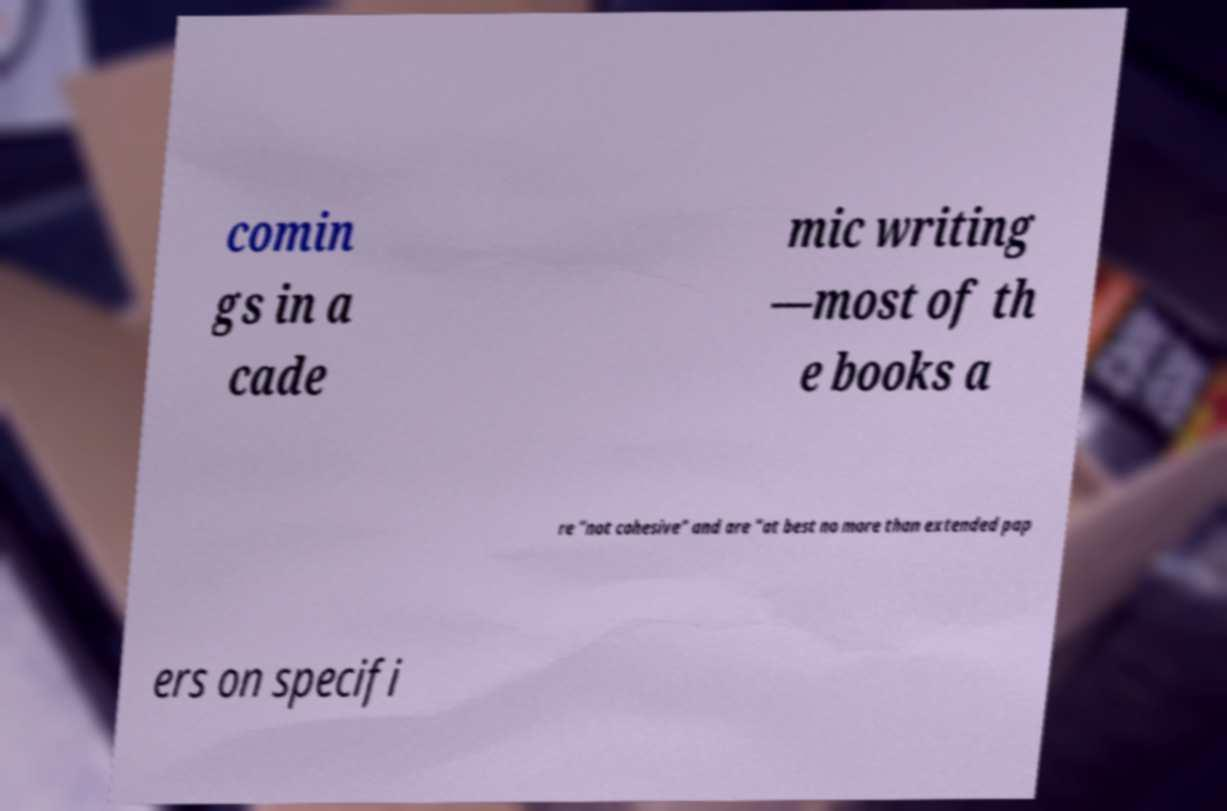Can you read and provide the text displayed in the image?This photo seems to have some interesting text. Can you extract and type it out for me? comin gs in a cade mic writing —most of th e books a re "not cohesive" and are "at best no more than extended pap ers on specifi 